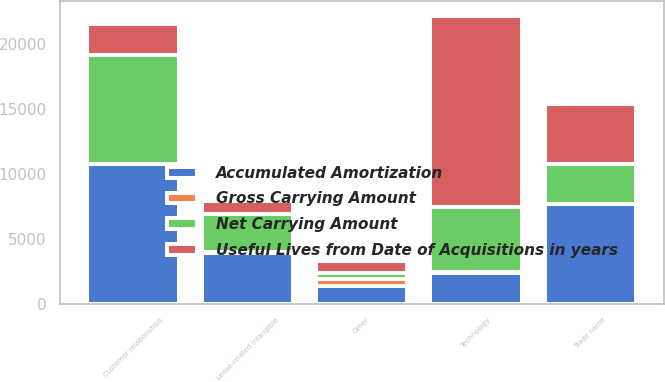Convert chart to OTSL. <chart><loc_0><loc_0><loc_500><loc_500><stacked_bar_chart><ecel><fcel>Technology<fcel>Customer relationships<fcel>Trade name<fcel>Lease-related intangible<fcel>Other<nl><fcel>Gross Carrying Amount<fcel>57<fcel>23<fcel>45<fcel>115<fcel>510<nl><fcel>Accumulated Amortization<fcel>2384<fcel>10738<fcel>7663<fcel>3896<fcel>1385<nl><fcel>Net Carrying Amount<fcel>5041<fcel>8354<fcel>3036<fcel>2919<fcel>444<nl><fcel>Useful Lives from Date of Acquisitions in years<fcel>14698<fcel>2384<fcel>4627<fcel>977<fcel>941<nl></chart> 